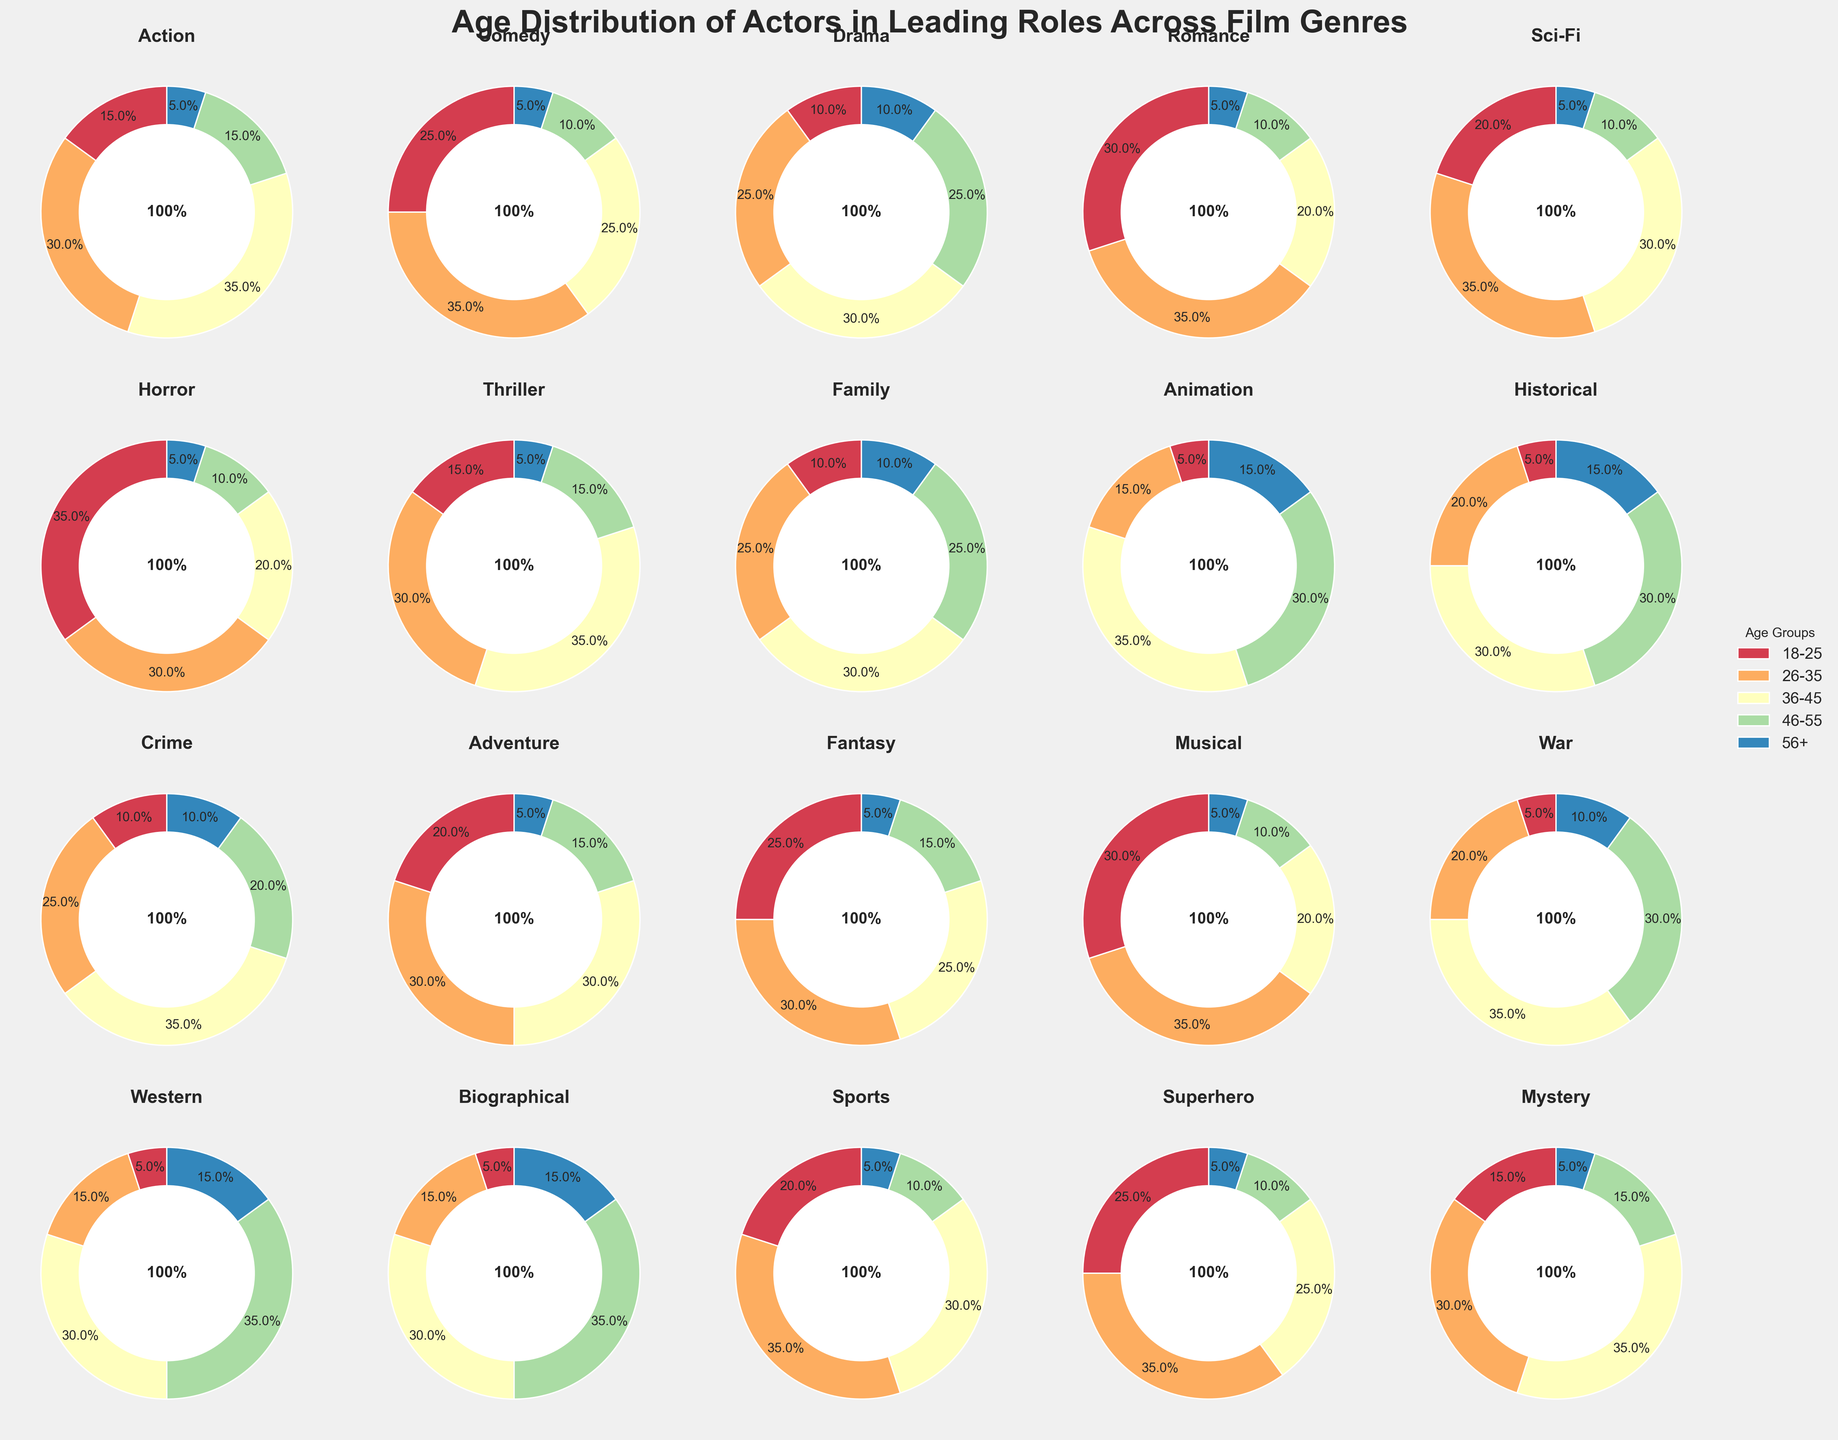Which genre has the highest percentage of actors aged 18-25? From the pie charts, Horror has the highest percentage for the age group 18-25, as the slice appears larger than in other genres.
Answer: Horror Which age group has the smallest percentage in the Action genre? In the Action pie chart, the smallest slice corresponds to the 56+ age group, indicating the lowest percentage.
Answer: 56+ Compare the percentage of actors aged 36-45 in the Sci-Fi and Thriller genres. Which is higher? Observing the sizes of the pie slices for the 36-45 age group in both genres, Sci-Fi has a slightly smaller slice than Thriller.
Answer: Thriller What is the combined percentage of actors aged 46 and older (46-55 and 56+) in the Romance genre? In the Romance pie chart, 46-55 is 10% and 56+ is 5%. Adding these gives 10% + 5% = 15%.
Answer: 15% Which genres have an equal percentage of actors aged 26-35? Both Comedy, Romance, Sci-Fi, Musical, and Sports have their 26-35 age group slices as 35%.
Answer: Comedy, Romance, Sci-Fi, Musical, Sports In which genre is the percentage of actors aged 18-25 twice as much as the percentage of actors aged 56+? In the Animation pie chart, 18-25 is 5% and 56+ is 15%. Thus, 18-25 is not twice the percentage of 56+. But in Horror, 18-25 is 35% and 56+ is 5%, making the 18-25 group exactly seven times larger.
Answer: Horror If you sum the percentages of actors aged 18-25 and 36-45 in the Family genre, what is the total? In the Family pie chart, 18-25 is 10% and 36-45 is 30%. Adding these gives 10% + 30% = 40%.
Answer: 40% Which genre has an equal percentage of actors aged 18-25 to Sci-Fi's percentage of actors aged 26-35? Sci-Fi's percentage for 26-35 is 35%. Checking the pie charts, Romantic and Musical both have 35% actors aged 18-25.
Answer: Romance, Musical Identify the genre with the smallest percentage of actors aged 18-25 that still has a higher percentage than that of Western. Western has 5% aged 18-25. Minimized genres with more than 5% include Animation, War, Historical, etc. Animation is the smallest of these, with only 5%.
Answer: Animation 